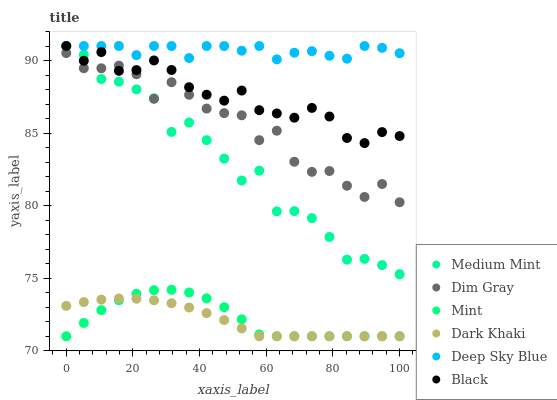Does Dark Khaki have the minimum area under the curve?
Answer yes or no. Yes. Does Deep Sky Blue have the maximum area under the curve?
Answer yes or no. Yes. Does Dim Gray have the minimum area under the curve?
Answer yes or no. No. Does Dim Gray have the maximum area under the curve?
Answer yes or no. No. Is Dark Khaki the smoothest?
Answer yes or no. Yes. Is Dim Gray the roughest?
Answer yes or no. Yes. Is Dim Gray the smoothest?
Answer yes or no. No. Is Dark Khaki the roughest?
Answer yes or no. No. Does Dark Khaki have the lowest value?
Answer yes or no. Yes. Does Dim Gray have the lowest value?
Answer yes or no. No. Does Deep Sky Blue have the highest value?
Answer yes or no. Yes. Does Dim Gray have the highest value?
Answer yes or no. No. Is Dark Khaki less than Medium Mint?
Answer yes or no. Yes. Is Medium Mint greater than Dark Khaki?
Answer yes or no. Yes. Does Mint intersect Dark Khaki?
Answer yes or no. Yes. Is Mint less than Dark Khaki?
Answer yes or no. No. Is Mint greater than Dark Khaki?
Answer yes or no. No. Does Dark Khaki intersect Medium Mint?
Answer yes or no. No. 